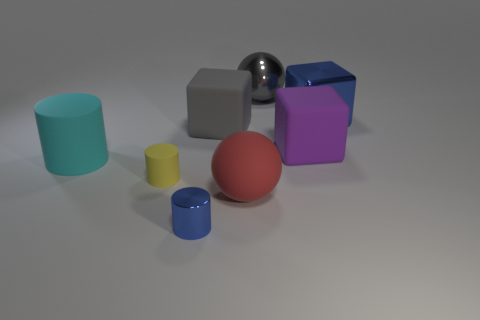Subtract all matte cylinders. How many cylinders are left? 1 Subtract all blue blocks. How many blocks are left? 2 Subtract all cylinders. How many objects are left? 5 Subtract 1 balls. How many balls are left? 1 Subtract 0 yellow spheres. How many objects are left? 8 Subtract all red blocks. Subtract all blue cylinders. How many blocks are left? 3 Subtract all purple spheres. How many green blocks are left? 0 Subtract all blue metallic cubes. Subtract all blue spheres. How many objects are left? 7 Add 4 small blue metal cylinders. How many small blue metal cylinders are left? 5 Add 2 blue blocks. How many blue blocks exist? 3 